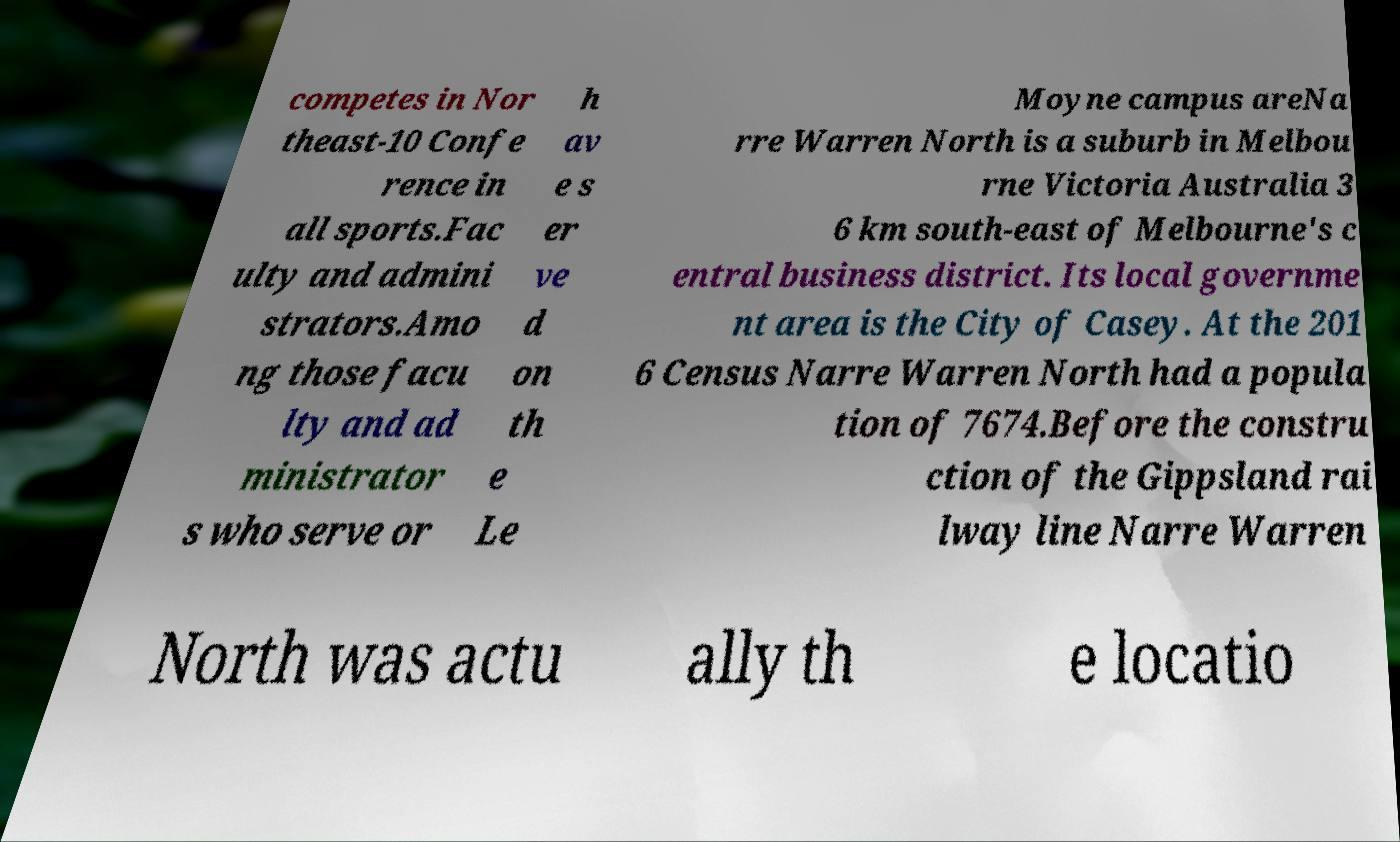Please identify and transcribe the text found in this image. competes in Nor theast-10 Confe rence in all sports.Fac ulty and admini strators.Amo ng those facu lty and ad ministrator s who serve or h av e s er ve d on th e Le Moyne campus areNa rre Warren North is a suburb in Melbou rne Victoria Australia 3 6 km south-east of Melbourne's c entral business district. Its local governme nt area is the City of Casey. At the 201 6 Census Narre Warren North had a popula tion of 7674.Before the constru ction of the Gippsland rai lway line Narre Warren North was actu ally th e locatio 